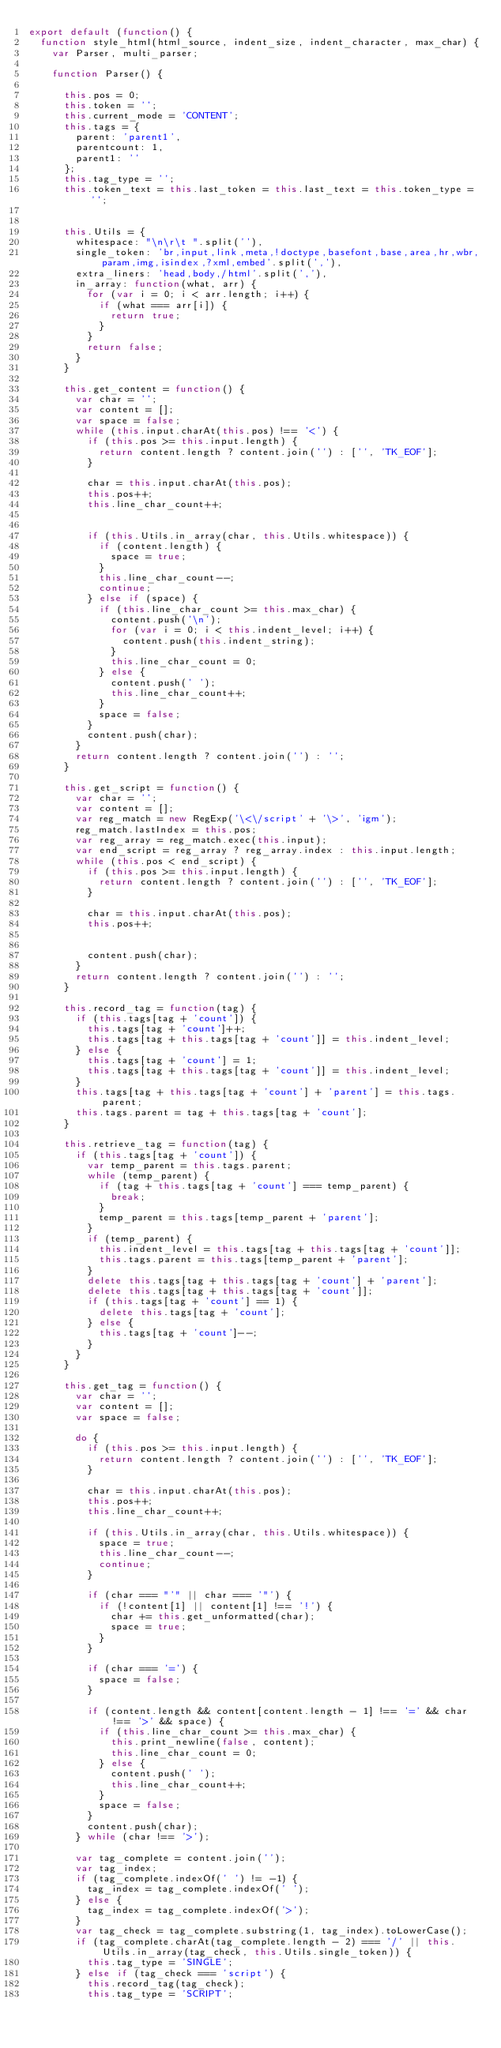Convert code to text. <code><loc_0><loc_0><loc_500><loc_500><_JavaScript_>export default (function() {
  function style_html(html_source, indent_size, indent_character, max_char) {
    var Parser, multi_parser;

    function Parser() {

      this.pos = 0;
      this.token = '';
      this.current_mode = 'CONTENT';
      this.tags = {
        parent: 'parent1',
        parentcount: 1,
        parent1: ''
      };
      this.tag_type = '';
      this.token_text = this.last_token = this.last_text = this.token_type = '';


      this.Utils = {
        whitespace: "\n\r\t ".split(''),
        single_token: 'br,input,link,meta,!doctype,basefont,base,area,hr,wbr,param,img,isindex,?xml,embed'.split(','),
        extra_liners: 'head,body,/html'.split(','),
        in_array: function(what, arr) {
          for (var i = 0; i < arr.length; i++) {
            if (what === arr[i]) {
              return true;
            }
          }
          return false;
        }
      }

      this.get_content = function() {
        var char = '';
        var content = [];
        var space = false;
        while (this.input.charAt(this.pos) !== '<') {
          if (this.pos >= this.input.length) {
            return content.length ? content.join('') : ['', 'TK_EOF'];
          }

          char = this.input.charAt(this.pos);
          this.pos++;
          this.line_char_count++;


          if (this.Utils.in_array(char, this.Utils.whitespace)) {
            if (content.length) {
              space = true;
            }
            this.line_char_count--;
            continue;
          } else if (space) {
            if (this.line_char_count >= this.max_char) {
              content.push('\n');
              for (var i = 0; i < this.indent_level; i++) {
                content.push(this.indent_string);
              }
              this.line_char_count = 0;
            } else {
              content.push(' ');
              this.line_char_count++;
            }
            space = false;
          }
          content.push(char);
        }
        return content.length ? content.join('') : '';
      }

      this.get_script = function() {
        var char = '';
        var content = [];
        var reg_match = new RegExp('\<\/script' + '\>', 'igm');
        reg_match.lastIndex = this.pos;
        var reg_array = reg_match.exec(this.input);
        var end_script = reg_array ? reg_array.index : this.input.length;
        while (this.pos < end_script) {
          if (this.pos >= this.input.length) {
            return content.length ? content.join('') : ['', 'TK_EOF'];
          }

          char = this.input.charAt(this.pos);
          this.pos++;


          content.push(char);
        }
        return content.length ? content.join('') : '';
      }

      this.record_tag = function(tag) {
        if (this.tags[tag + 'count']) {
          this.tags[tag + 'count']++;
          this.tags[tag + this.tags[tag + 'count']] = this.indent_level;
        } else {
          this.tags[tag + 'count'] = 1;
          this.tags[tag + this.tags[tag + 'count']] = this.indent_level;
        }
        this.tags[tag + this.tags[tag + 'count'] + 'parent'] = this.tags.parent;
        this.tags.parent = tag + this.tags[tag + 'count'];
      }

      this.retrieve_tag = function(tag) {
        if (this.tags[tag + 'count']) {
          var temp_parent = this.tags.parent;
          while (temp_parent) {
            if (tag + this.tags[tag + 'count'] === temp_parent) {
              break;
            }
            temp_parent = this.tags[temp_parent + 'parent'];
          }
          if (temp_parent) {
            this.indent_level = this.tags[tag + this.tags[tag + 'count']];
            this.tags.parent = this.tags[temp_parent + 'parent'];
          }
          delete this.tags[tag + this.tags[tag + 'count'] + 'parent'];
          delete this.tags[tag + this.tags[tag + 'count']];
          if (this.tags[tag + 'count'] == 1) {
            delete this.tags[tag + 'count'];
          } else {
            this.tags[tag + 'count']--;
          }
        }
      }

      this.get_tag = function() {
        var char = '';
        var content = [];
        var space = false;

        do {
          if (this.pos >= this.input.length) {
            return content.length ? content.join('') : ['', 'TK_EOF'];
          }

          char = this.input.charAt(this.pos);
          this.pos++;
          this.line_char_count++;

          if (this.Utils.in_array(char, this.Utils.whitespace)) {
            space = true;
            this.line_char_count--;
            continue;
          }

          if (char === "'" || char === '"') {
            if (!content[1] || content[1] !== '!') {
              char += this.get_unformatted(char);
              space = true;
            }
          }

          if (char === '=') {
            space = false;
          }

          if (content.length && content[content.length - 1] !== '=' && char !== '>' && space) {
            if (this.line_char_count >= this.max_char) {
              this.print_newline(false, content);
              this.line_char_count = 0;
            } else {
              content.push(' ');
              this.line_char_count++;
            }
            space = false;
          }
          content.push(char);
        } while (char !== '>');

        var tag_complete = content.join('');
        var tag_index;
        if (tag_complete.indexOf(' ') != -1) {
          tag_index = tag_complete.indexOf(' ');
        } else {
          tag_index = tag_complete.indexOf('>');
        }
        var tag_check = tag_complete.substring(1, tag_index).toLowerCase();
        if (tag_complete.charAt(tag_complete.length - 2) === '/' || this.Utils.in_array(tag_check, this.Utils.single_token)) {
          this.tag_type = 'SINGLE';
        } else if (tag_check === 'script') {
          this.record_tag(tag_check);
          this.tag_type = 'SCRIPT';</code> 